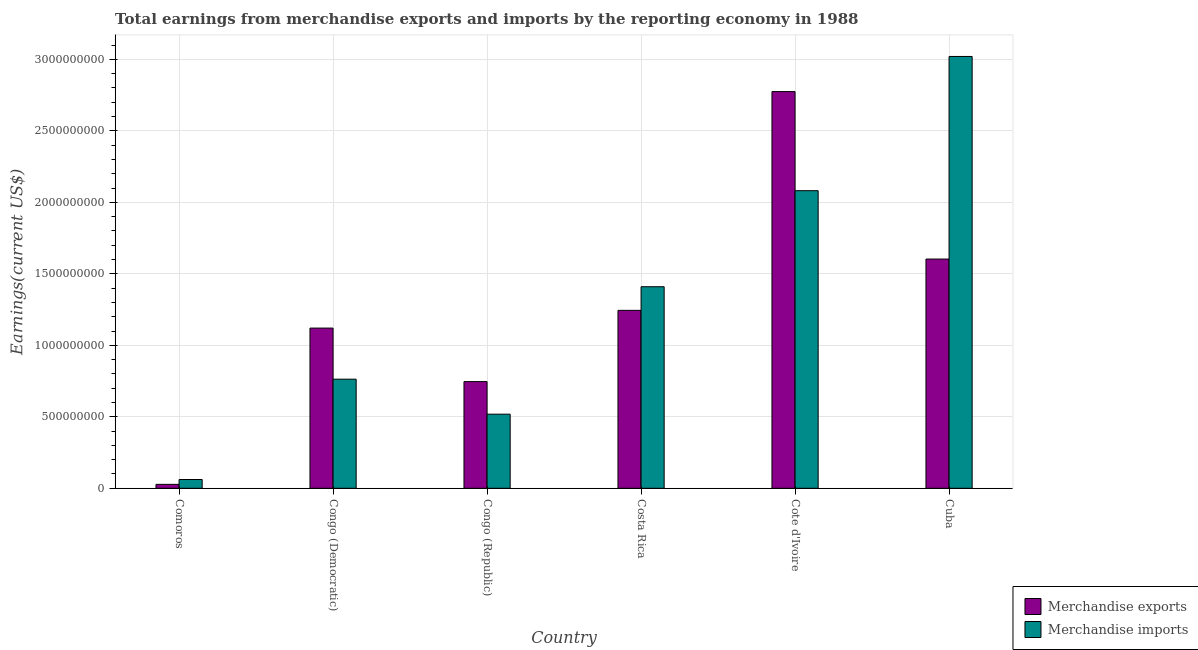How many different coloured bars are there?
Give a very brief answer. 2. How many groups of bars are there?
Keep it short and to the point. 6. How many bars are there on the 6th tick from the right?
Offer a very short reply. 2. What is the label of the 5th group of bars from the left?
Offer a terse response. Cote d'Ivoire. What is the earnings from merchandise exports in Cote d'Ivoire?
Ensure brevity in your answer.  2.77e+09. Across all countries, what is the maximum earnings from merchandise exports?
Your response must be concise. 2.77e+09. Across all countries, what is the minimum earnings from merchandise exports?
Ensure brevity in your answer.  2.75e+07. In which country was the earnings from merchandise exports maximum?
Your answer should be compact. Cote d'Ivoire. In which country was the earnings from merchandise imports minimum?
Your answer should be very brief. Comoros. What is the total earnings from merchandise exports in the graph?
Your answer should be compact. 7.52e+09. What is the difference between the earnings from merchandise imports in Congo (Republic) and that in Cote d'Ivoire?
Keep it short and to the point. -1.56e+09. What is the difference between the earnings from merchandise exports in Comoros and the earnings from merchandise imports in Congo (Democratic)?
Make the answer very short. -7.36e+08. What is the average earnings from merchandise exports per country?
Offer a terse response. 1.25e+09. What is the difference between the earnings from merchandise imports and earnings from merchandise exports in Cote d'Ivoire?
Ensure brevity in your answer.  -6.93e+08. In how many countries, is the earnings from merchandise exports greater than 2500000000 US$?
Your answer should be compact. 1. What is the ratio of the earnings from merchandise exports in Costa Rica to that in Cote d'Ivoire?
Your answer should be compact. 0.45. Is the earnings from merchandise exports in Comoros less than that in Cuba?
Ensure brevity in your answer.  Yes. What is the difference between the highest and the second highest earnings from merchandise exports?
Give a very brief answer. 1.17e+09. What is the difference between the highest and the lowest earnings from merchandise imports?
Your response must be concise. 2.96e+09. In how many countries, is the earnings from merchandise imports greater than the average earnings from merchandise imports taken over all countries?
Your answer should be compact. 3. Is the sum of the earnings from merchandise exports in Congo (Democratic) and Cote d'Ivoire greater than the maximum earnings from merchandise imports across all countries?
Provide a succinct answer. Yes. What does the 2nd bar from the left in Congo (Democratic) represents?
Offer a terse response. Merchandise imports. What does the 1st bar from the right in Congo (Republic) represents?
Your response must be concise. Merchandise imports. How many bars are there?
Provide a short and direct response. 12. Are all the bars in the graph horizontal?
Your answer should be very brief. No. What is the difference between two consecutive major ticks on the Y-axis?
Ensure brevity in your answer.  5.00e+08. Are the values on the major ticks of Y-axis written in scientific E-notation?
Give a very brief answer. No. What is the title of the graph?
Offer a terse response. Total earnings from merchandise exports and imports by the reporting economy in 1988. What is the label or title of the X-axis?
Your answer should be compact. Country. What is the label or title of the Y-axis?
Provide a succinct answer. Earnings(current US$). What is the Earnings(current US$) of Merchandise exports in Comoros?
Provide a succinct answer. 2.75e+07. What is the Earnings(current US$) of Merchandise imports in Comoros?
Provide a succinct answer. 6.14e+07. What is the Earnings(current US$) of Merchandise exports in Congo (Democratic)?
Your response must be concise. 1.12e+09. What is the Earnings(current US$) of Merchandise imports in Congo (Democratic)?
Your answer should be very brief. 7.63e+08. What is the Earnings(current US$) in Merchandise exports in Congo (Republic)?
Your response must be concise. 7.46e+08. What is the Earnings(current US$) of Merchandise imports in Congo (Republic)?
Keep it short and to the point. 5.18e+08. What is the Earnings(current US$) in Merchandise exports in Costa Rica?
Your response must be concise. 1.24e+09. What is the Earnings(current US$) of Merchandise imports in Costa Rica?
Your answer should be compact. 1.41e+09. What is the Earnings(current US$) in Merchandise exports in Cote d'Ivoire?
Your answer should be compact. 2.77e+09. What is the Earnings(current US$) in Merchandise imports in Cote d'Ivoire?
Make the answer very short. 2.08e+09. What is the Earnings(current US$) in Merchandise exports in Cuba?
Offer a very short reply. 1.60e+09. What is the Earnings(current US$) in Merchandise imports in Cuba?
Give a very brief answer. 3.02e+09. Across all countries, what is the maximum Earnings(current US$) in Merchandise exports?
Your response must be concise. 2.77e+09. Across all countries, what is the maximum Earnings(current US$) in Merchandise imports?
Your answer should be very brief. 3.02e+09. Across all countries, what is the minimum Earnings(current US$) in Merchandise exports?
Your answer should be very brief. 2.75e+07. Across all countries, what is the minimum Earnings(current US$) of Merchandise imports?
Make the answer very short. 6.14e+07. What is the total Earnings(current US$) in Merchandise exports in the graph?
Provide a short and direct response. 7.52e+09. What is the total Earnings(current US$) in Merchandise imports in the graph?
Make the answer very short. 7.85e+09. What is the difference between the Earnings(current US$) of Merchandise exports in Comoros and that in Congo (Democratic)?
Offer a terse response. -1.09e+09. What is the difference between the Earnings(current US$) in Merchandise imports in Comoros and that in Congo (Democratic)?
Make the answer very short. -7.02e+08. What is the difference between the Earnings(current US$) of Merchandise exports in Comoros and that in Congo (Republic)?
Make the answer very short. -7.19e+08. What is the difference between the Earnings(current US$) in Merchandise imports in Comoros and that in Congo (Republic)?
Make the answer very short. -4.57e+08. What is the difference between the Earnings(current US$) in Merchandise exports in Comoros and that in Costa Rica?
Provide a short and direct response. -1.22e+09. What is the difference between the Earnings(current US$) in Merchandise imports in Comoros and that in Costa Rica?
Your response must be concise. -1.35e+09. What is the difference between the Earnings(current US$) in Merchandise exports in Comoros and that in Cote d'Ivoire?
Your answer should be very brief. -2.75e+09. What is the difference between the Earnings(current US$) of Merchandise imports in Comoros and that in Cote d'Ivoire?
Your response must be concise. -2.02e+09. What is the difference between the Earnings(current US$) of Merchandise exports in Comoros and that in Cuba?
Offer a very short reply. -1.58e+09. What is the difference between the Earnings(current US$) of Merchandise imports in Comoros and that in Cuba?
Your answer should be compact. -2.96e+09. What is the difference between the Earnings(current US$) in Merchandise exports in Congo (Democratic) and that in Congo (Republic)?
Your response must be concise. 3.74e+08. What is the difference between the Earnings(current US$) in Merchandise imports in Congo (Democratic) and that in Congo (Republic)?
Your answer should be very brief. 2.45e+08. What is the difference between the Earnings(current US$) of Merchandise exports in Congo (Democratic) and that in Costa Rica?
Ensure brevity in your answer.  -1.24e+08. What is the difference between the Earnings(current US$) in Merchandise imports in Congo (Democratic) and that in Costa Rica?
Give a very brief answer. -6.47e+08. What is the difference between the Earnings(current US$) of Merchandise exports in Congo (Democratic) and that in Cote d'Ivoire?
Give a very brief answer. -1.65e+09. What is the difference between the Earnings(current US$) in Merchandise imports in Congo (Democratic) and that in Cote d'Ivoire?
Make the answer very short. -1.32e+09. What is the difference between the Earnings(current US$) in Merchandise exports in Congo (Democratic) and that in Cuba?
Provide a short and direct response. -4.83e+08. What is the difference between the Earnings(current US$) in Merchandise imports in Congo (Democratic) and that in Cuba?
Offer a terse response. -2.26e+09. What is the difference between the Earnings(current US$) of Merchandise exports in Congo (Republic) and that in Costa Rica?
Offer a very short reply. -4.98e+08. What is the difference between the Earnings(current US$) of Merchandise imports in Congo (Republic) and that in Costa Rica?
Ensure brevity in your answer.  -8.92e+08. What is the difference between the Earnings(current US$) of Merchandise exports in Congo (Republic) and that in Cote d'Ivoire?
Provide a short and direct response. -2.03e+09. What is the difference between the Earnings(current US$) of Merchandise imports in Congo (Republic) and that in Cote d'Ivoire?
Give a very brief answer. -1.56e+09. What is the difference between the Earnings(current US$) in Merchandise exports in Congo (Republic) and that in Cuba?
Your answer should be compact. -8.57e+08. What is the difference between the Earnings(current US$) in Merchandise imports in Congo (Republic) and that in Cuba?
Keep it short and to the point. -2.50e+09. What is the difference between the Earnings(current US$) of Merchandise exports in Costa Rica and that in Cote d'Ivoire?
Your answer should be very brief. -1.53e+09. What is the difference between the Earnings(current US$) in Merchandise imports in Costa Rica and that in Cote d'Ivoire?
Offer a terse response. -6.72e+08. What is the difference between the Earnings(current US$) of Merchandise exports in Costa Rica and that in Cuba?
Your answer should be very brief. -3.59e+08. What is the difference between the Earnings(current US$) of Merchandise imports in Costa Rica and that in Cuba?
Offer a terse response. -1.61e+09. What is the difference between the Earnings(current US$) in Merchandise exports in Cote d'Ivoire and that in Cuba?
Keep it short and to the point. 1.17e+09. What is the difference between the Earnings(current US$) in Merchandise imports in Cote d'Ivoire and that in Cuba?
Your answer should be very brief. -9.39e+08. What is the difference between the Earnings(current US$) in Merchandise exports in Comoros and the Earnings(current US$) in Merchandise imports in Congo (Democratic)?
Your answer should be very brief. -7.36e+08. What is the difference between the Earnings(current US$) in Merchandise exports in Comoros and the Earnings(current US$) in Merchandise imports in Congo (Republic)?
Offer a very short reply. -4.91e+08. What is the difference between the Earnings(current US$) in Merchandise exports in Comoros and the Earnings(current US$) in Merchandise imports in Costa Rica?
Provide a short and direct response. -1.38e+09. What is the difference between the Earnings(current US$) of Merchandise exports in Comoros and the Earnings(current US$) of Merchandise imports in Cote d'Ivoire?
Your response must be concise. -2.05e+09. What is the difference between the Earnings(current US$) of Merchandise exports in Comoros and the Earnings(current US$) of Merchandise imports in Cuba?
Give a very brief answer. -2.99e+09. What is the difference between the Earnings(current US$) in Merchandise exports in Congo (Democratic) and the Earnings(current US$) in Merchandise imports in Congo (Republic)?
Keep it short and to the point. 6.02e+08. What is the difference between the Earnings(current US$) in Merchandise exports in Congo (Democratic) and the Earnings(current US$) in Merchandise imports in Costa Rica?
Give a very brief answer. -2.89e+08. What is the difference between the Earnings(current US$) in Merchandise exports in Congo (Democratic) and the Earnings(current US$) in Merchandise imports in Cote d'Ivoire?
Offer a terse response. -9.61e+08. What is the difference between the Earnings(current US$) in Merchandise exports in Congo (Democratic) and the Earnings(current US$) in Merchandise imports in Cuba?
Your answer should be very brief. -1.90e+09. What is the difference between the Earnings(current US$) in Merchandise exports in Congo (Republic) and the Earnings(current US$) in Merchandise imports in Costa Rica?
Make the answer very short. -6.64e+08. What is the difference between the Earnings(current US$) in Merchandise exports in Congo (Republic) and the Earnings(current US$) in Merchandise imports in Cote d'Ivoire?
Give a very brief answer. -1.34e+09. What is the difference between the Earnings(current US$) of Merchandise exports in Congo (Republic) and the Earnings(current US$) of Merchandise imports in Cuba?
Offer a terse response. -2.27e+09. What is the difference between the Earnings(current US$) in Merchandise exports in Costa Rica and the Earnings(current US$) in Merchandise imports in Cote d'Ivoire?
Ensure brevity in your answer.  -8.37e+08. What is the difference between the Earnings(current US$) in Merchandise exports in Costa Rica and the Earnings(current US$) in Merchandise imports in Cuba?
Provide a succinct answer. -1.78e+09. What is the difference between the Earnings(current US$) in Merchandise exports in Cote d'Ivoire and the Earnings(current US$) in Merchandise imports in Cuba?
Provide a succinct answer. -2.46e+08. What is the average Earnings(current US$) in Merchandise exports per country?
Keep it short and to the point. 1.25e+09. What is the average Earnings(current US$) in Merchandise imports per country?
Offer a very short reply. 1.31e+09. What is the difference between the Earnings(current US$) of Merchandise exports and Earnings(current US$) of Merchandise imports in Comoros?
Provide a short and direct response. -3.39e+07. What is the difference between the Earnings(current US$) of Merchandise exports and Earnings(current US$) of Merchandise imports in Congo (Democratic)?
Keep it short and to the point. 3.57e+08. What is the difference between the Earnings(current US$) of Merchandise exports and Earnings(current US$) of Merchandise imports in Congo (Republic)?
Keep it short and to the point. 2.28e+08. What is the difference between the Earnings(current US$) of Merchandise exports and Earnings(current US$) of Merchandise imports in Costa Rica?
Make the answer very short. -1.65e+08. What is the difference between the Earnings(current US$) of Merchandise exports and Earnings(current US$) of Merchandise imports in Cote d'Ivoire?
Make the answer very short. 6.93e+08. What is the difference between the Earnings(current US$) of Merchandise exports and Earnings(current US$) of Merchandise imports in Cuba?
Your answer should be very brief. -1.42e+09. What is the ratio of the Earnings(current US$) of Merchandise exports in Comoros to that in Congo (Democratic)?
Offer a very short reply. 0.02. What is the ratio of the Earnings(current US$) in Merchandise imports in Comoros to that in Congo (Democratic)?
Provide a short and direct response. 0.08. What is the ratio of the Earnings(current US$) in Merchandise exports in Comoros to that in Congo (Republic)?
Your answer should be very brief. 0.04. What is the ratio of the Earnings(current US$) in Merchandise imports in Comoros to that in Congo (Republic)?
Offer a terse response. 0.12. What is the ratio of the Earnings(current US$) in Merchandise exports in Comoros to that in Costa Rica?
Offer a terse response. 0.02. What is the ratio of the Earnings(current US$) of Merchandise imports in Comoros to that in Costa Rica?
Offer a terse response. 0.04. What is the ratio of the Earnings(current US$) of Merchandise exports in Comoros to that in Cote d'Ivoire?
Offer a terse response. 0.01. What is the ratio of the Earnings(current US$) of Merchandise imports in Comoros to that in Cote d'Ivoire?
Provide a succinct answer. 0.03. What is the ratio of the Earnings(current US$) of Merchandise exports in Comoros to that in Cuba?
Provide a succinct answer. 0.02. What is the ratio of the Earnings(current US$) of Merchandise imports in Comoros to that in Cuba?
Keep it short and to the point. 0.02. What is the ratio of the Earnings(current US$) in Merchandise exports in Congo (Democratic) to that in Congo (Republic)?
Your response must be concise. 1.5. What is the ratio of the Earnings(current US$) of Merchandise imports in Congo (Democratic) to that in Congo (Republic)?
Offer a very short reply. 1.47. What is the ratio of the Earnings(current US$) of Merchandise exports in Congo (Democratic) to that in Costa Rica?
Your answer should be very brief. 0.9. What is the ratio of the Earnings(current US$) of Merchandise imports in Congo (Democratic) to that in Costa Rica?
Offer a terse response. 0.54. What is the ratio of the Earnings(current US$) of Merchandise exports in Congo (Democratic) to that in Cote d'Ivoire?
Offer a very short reply. 0.4. What is the ratio of the Earnings(current US$) in Merchandise imports in Congo (Democratic) to that in Cote d'Ivoire?
Ensure brevity in your answer.  0.37. What is the ratio of the Earnings(current US$) of Merchandise exports in Congo (Democratic) to that in Cuba?
Your answer should be compact. 0.7. What is the ratio of the Earnings(current US$) of Merchandise imports in Congo (Democratic) to that in Cuba?
Your answer should be very brief. 0.25. What is the ratio of the Earnings(current US$) of Merchandise exports in Congo (Republic) to that in Costa Rica?
Offer a terse response. 0.6. What is the ratio of the Earnings(current US$) of Merchandise imports in Congo (Republic) to that in Costa Rica?
Your response must be concise. 0.37. What is the ratio of the Earnings(current US$) of Merchandise exports in Congo (Republic) to that in Cote d'Ivoire?
Your answer should be compact. 0.27. What is the ratio of the Earnings(current US$) of Merchandise imports in Congo (Republic) to that in Cote d'Ivoire?
Give a very brief answer. 0.25. What is the ratio of the Earnings(current US$) in Merchandise exports in Congo (Republic) to that in Cuba?
Your response must be concise. 0.47. What is the ratio of the Earnings(current US$) in Merchandise imports in Congo (Republic) to that in Cuba?
Your answer should be compact. 0.17. What is the ratio of the Earnings(current US$) in Merchandise exports in Costa Rica to that in Cote d'Ivoire?
Your answer should be very brief. 0.45. What is the ratio of the Earnings(current US$) in Merchandise imports in Costa Rica to that in Cote d'Ivoire?
Your response must be concise. 0.68. What is the ratio of the Earnings(current US$) in Merchandise exports in Costa Rica to that in Cuba?
Your response must be concise. 0.78. What is the ratio of the Earnings(current US$) of Merchandise imports in Costa Rica to that in Cuba?
Your response must be concise. 0.47. What is the ratio of the Earnings(current US$) of Merchandise exports in Cote d'Ivoire to that in Cuba?
Keep it short and to the point. 1.73. What is the ratio of the Earnings(current US$) in Merchandise imports in Cote d'Ivoire to that in Cuba?
Give a very brief answer. 0.69. What is the difference between the highest and the second highest Earnings(current US$) in Merchandise exports?
Offer a terse response. 1.17e+09. What is the difference between the highest and the second highest Earnings(current US$) of Merchandise imports?
Make the answer very short. 9.39e+08. What is the difference between the highest and the lowest Earnings(current US$) in Merchandise exports?
Keep it short and to the point. 2.75e+09. What is the difference between the highest and the lowest Earnings(current US$) in Merchandise imports?
Give a very brief answer. 2.96e+09. 